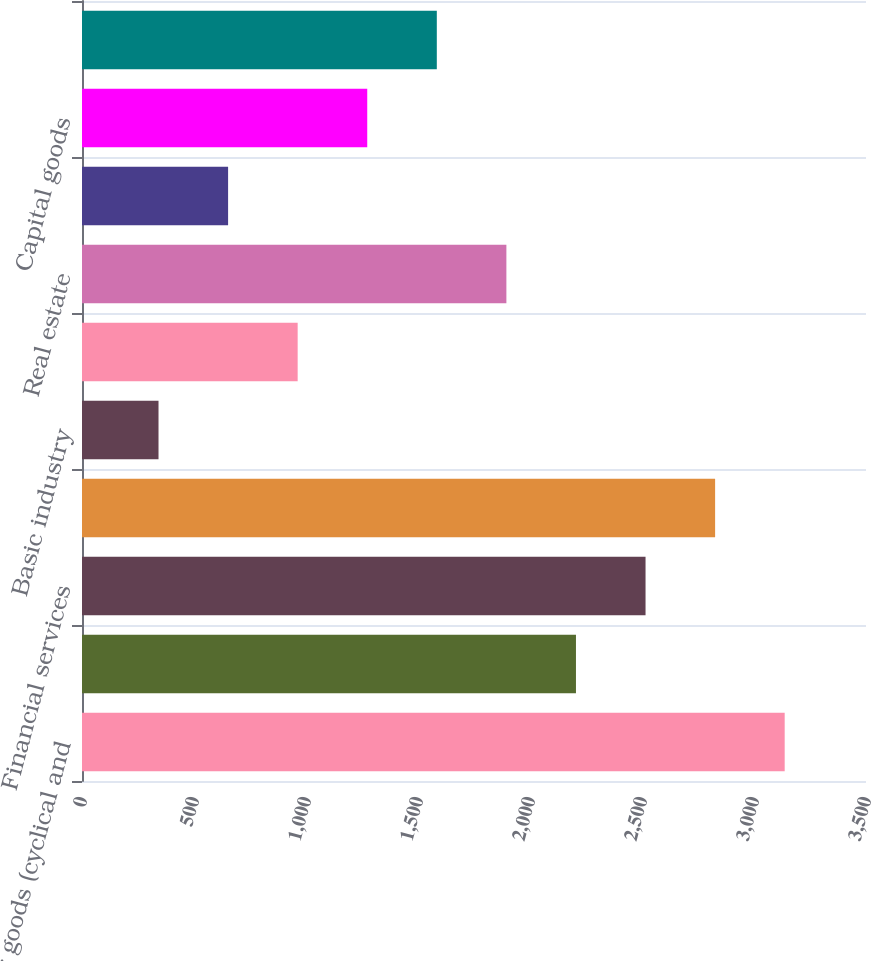Convert chart to OTSL. <chart><loc_0><loc_0><loc_500><loc_500><bar_chart><fcel>Consumer goods (cyclical and<fcel>Banking<fcel>Financial services<fcel>Energy<fcel>Basic industry<fcel>Utilities<fcel>Real estate<fcel>Technology<fcel>Capital goods<fcel>Communications<nl><fcel>3137<fcel>2205.2<fcel>2515.8<fcel>2826.4<fcel>341.6<fcel>962.8<fcel>1894.6<fcel>652.2<fcel>1273.4<fcel>1584<nl></chart> 